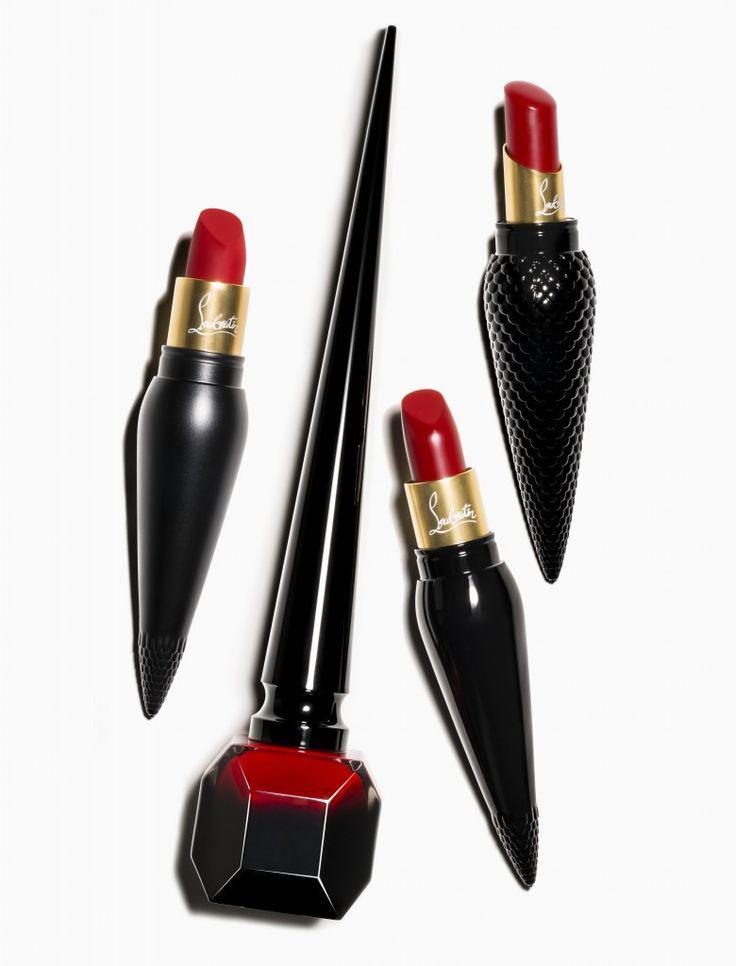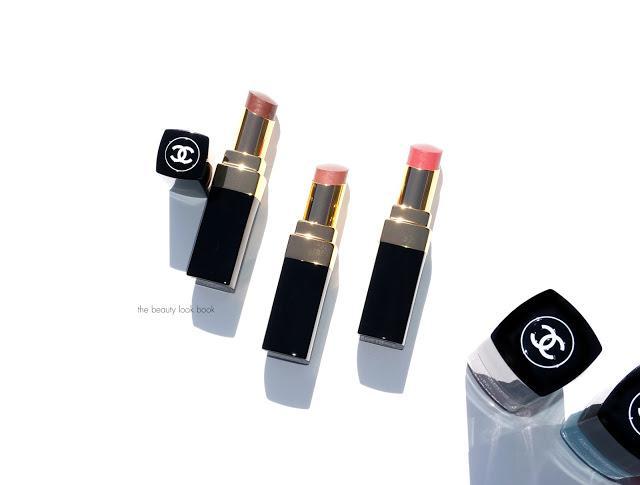The first image is the image on the left, the second image is the image on the right. Assess this claim about the two images: "There are at least 9 objects standing straight up in the right image.". Correct or not? Answer yes or no. No. 